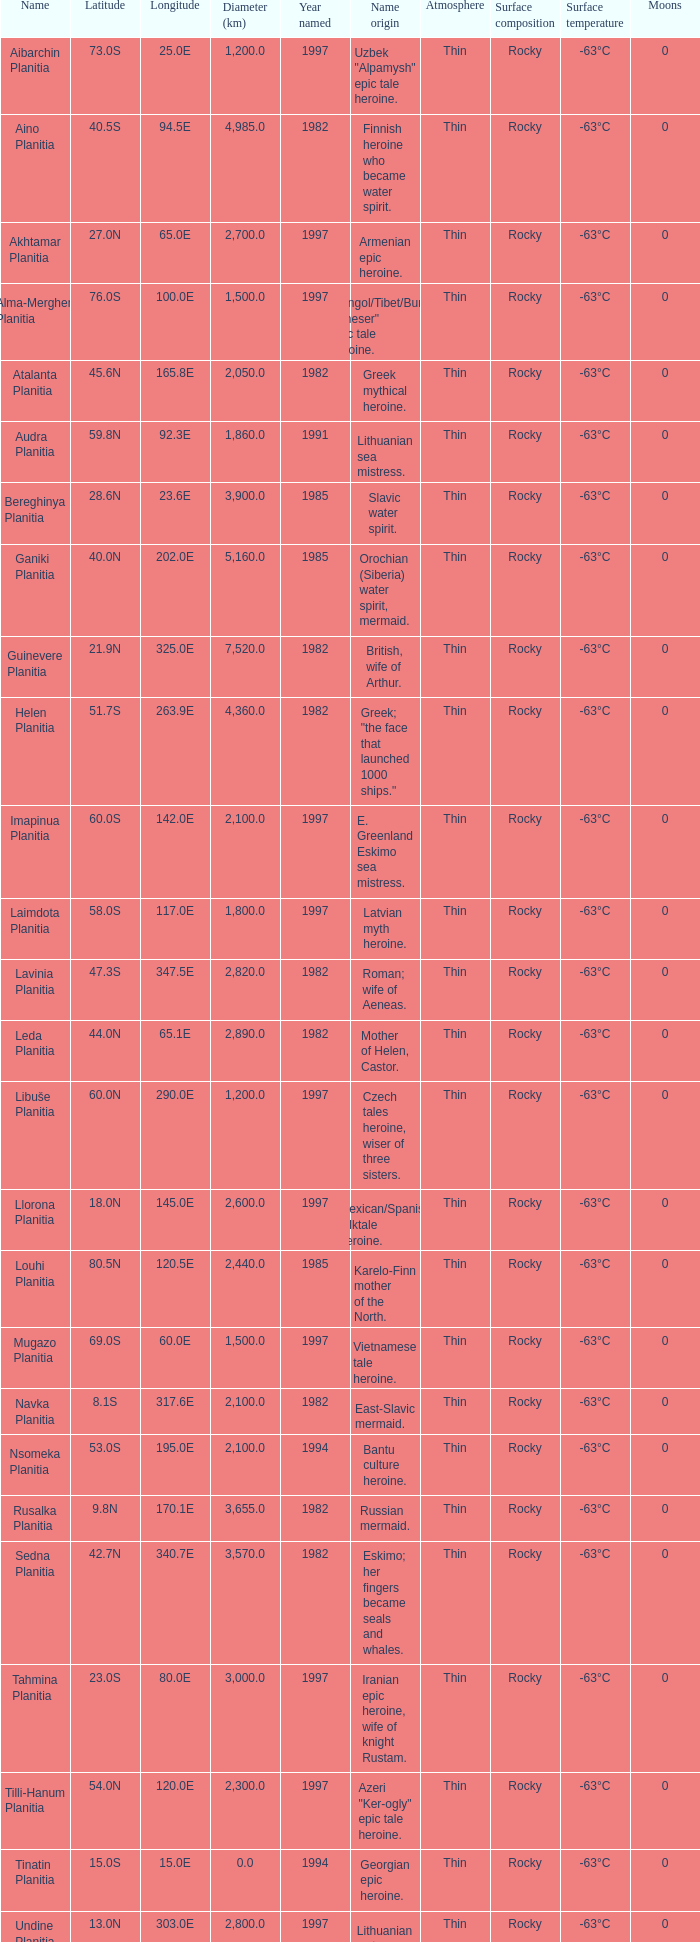What is the diameter (km) of longitude 170.1e 3655.0. 